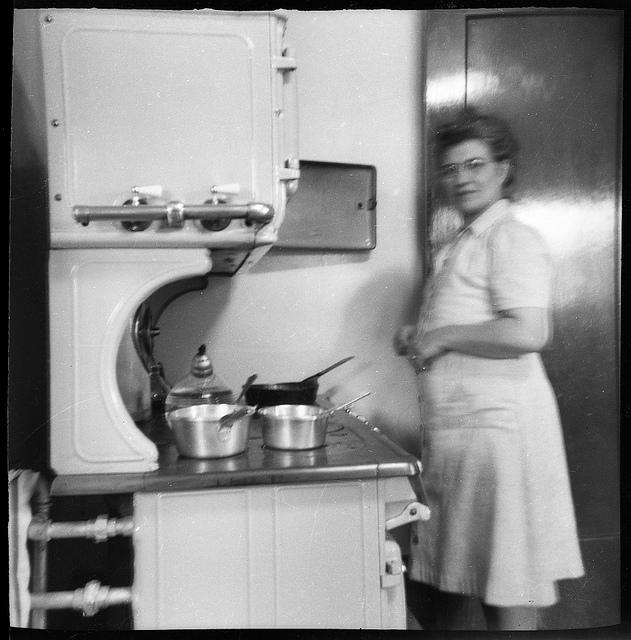Is this girl watching herself in the mirror?
Write a very short answer. No. Is the picture in color?
Keep it brief. No. What is the woman doing in the kitchen with the pans?
Be succinct. Cooking. Is this an old photo?
Give a very brief answer. Yes. 